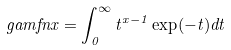<formula> <loc_0><loc_0><loc_500><loc_500>\ g a m f n { x } = \int _ { 0 } ^ { \infty } t ^ { x - 1 } \exp ( - t ) d t</formula> 